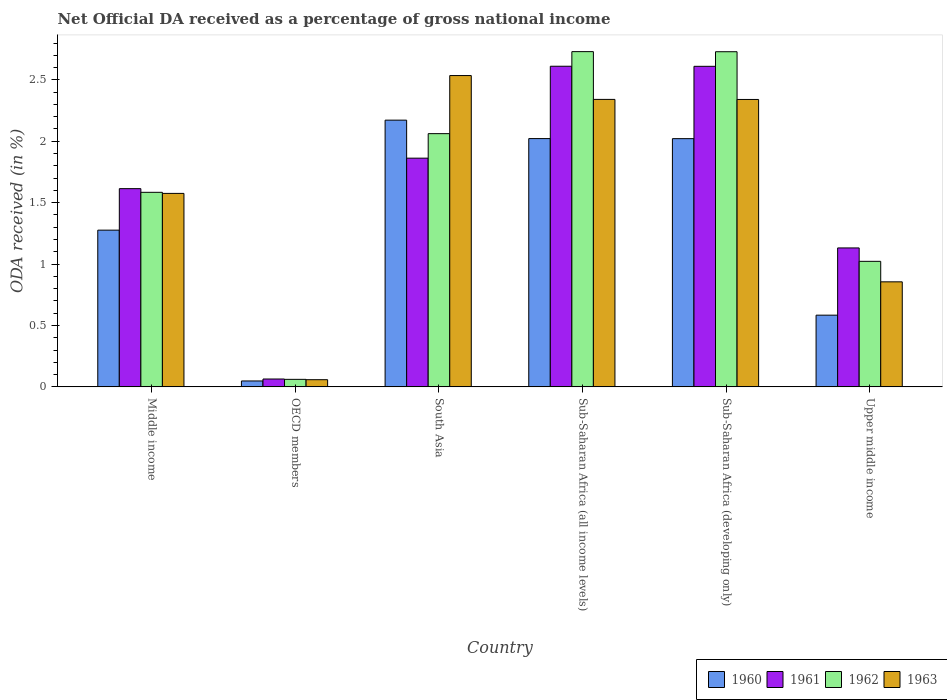How many different coloured bars are there?
Provide a succinct answer. 4. How many groups of bars are there?
Provide a succinct answer. 6. Are the number of bars per tick equal to the number of legend labels?
Your answer should be compact. Yes. Are the number of bars on each tick of the X-axis equal?
Provide a succinct answer. Yes. How many bars are there on the 3rd tick from the left?
Offer a very short reply. 4. How many bars are there on the 6th tick from the right?
Your response must be concise. 4. What is the net official DA received in 1962 in Middle income?
Your answer should be very brief. 1.58. Across all countries, what is the maximum net official DA received in 1960?
Make the answer very short. 2.17. Across all countries, what is the minimum net official DA received in 1961?
Ensure brevity in your answer.  0.06. What is the total net official DA received in 1962 in the graph?
Provide a short and direct response. 10.19. What is the difference between the net official DA received in 1963 in Middle income and that in Upper middle income?
Offer a terse response. 0.72. What is the difference between the net official DA received in 1962 in Upper middle income and the net official DA received in 1960 in Middle income?
Offer a terse response. -0.25. What is the average net official DA received in 1962 per country?
Give a very brief answer. 1.7. What is the difference between the net official DA received of/in 1963 and net official DA received of/in 1962 in Middle income?
Your answer should be very brief. -0.01. What is the ratio of the net official DA received in 1962 in South Asia to that in Sub-Saharan Africa (developing only)?
Provide a succinct answer. 0.76. Is the net official DA received in 1961 in Middle income less than that in South Asia?
Give a very brief answer. Yes. Is the difference between the net official DA received in 1963 in South Asia and Upper middle income greater than the difference between the net official DA received in 1962 in South Asia and Upper middle income?
Offer a very short reply. Yes. What is the difference between the highest and the second highest net official DA received in 1963?
Your answer should be very brief. 0.19. What is the difference between the highest and the lowest net official DA received in 1961?
Offer a very short reply. 2.55. Are all the bars in the graph horizontal?
Your response must be concise. No. What is the difference between two consecutive major ticks on the Y-axis?
Provide a short and direct response. 0.5. Does the graph contain any zero values?
Give a very brief answer. No. Where does the legend appear in the graph?
Offer a very short reply. Bottom right. How many legend labels are there?
Your answer should be compact. 4. How are the legend labels stacked?
Keep it short and to the point. Horizontal. What is the title of the graph?
Provide a succinct answer. Net Official DA received as a percentage of gross national income. Does "1983" appear as one of the legend labels in the graph?
Make the answer very short. No. What is the label or title of the Y-axis?
Your response must be concise. ODA received (in %). What is the ODA received (in %) of 1960 in Middle income?
Your answer should be compact. 1.28. What is the ODA received (in %) in 1961 in Middle income?
Give a very brief answer. 1.61. What is the ODA received (in %) of 1962 in Middle income?
Your response must be concise. 1.58. What is the ODA received (in %) of 1963 in Middle income?
Your response must be concise. 1.58. What is the ODA received (in %) of 1960 in OECD members?
Your answer should be very brief. 0.05. What is the ODA received (in %) in 1961 in OECD members?
Offer a terse response. 0.06. What is the ODA received (in %) in 1962 in OECD members?
Keep it short and to the point. 0.06. What is the ODA received (in %) in 1963 in OECD members?
Ensure brevity in your answer.  0.06. What is the ODA received (in %) of 1960 in South Asia?
Your response must be concise. 2.17. What is the ODA received (in %) in 1961 in South Asia?
Provide a short and direct response. 1.86. What is the ODA received (in %) in 1962 in South Asia?
Give a very brief answer. 2.06. What is the ODA received (in %) of 1963 in South Asia?
Keep it short and to the point. 2.53. What is the ODA received (in %) of 1960 in Sub-Saharan Africa (all income levels)?
Provide a short and direct response. 2.02. What is the ODA received (in %) of 1961 in Sub-Saharan Africa (all income levels)?
Your response must be concise. 2.61. What is the ODA received (in %) in 1962 in Sub-Saharan Africa (all income levels)?
Offer a terse response. 2.73. What is the ODA received (in %) in 1963 in Sub-Saharan Africa (all income levels)?
Your answer should be compact. 2.34. What is the ODA received (in %) of 1960 in Sub-Saharan Africa (developing only)?
Your answer should be compact. 2.02. What is the ODA received (in %) of 1961 in Sub-Saharan Africa (developing only)?
Provide a short and direct response. 2.61. What is the ODA received (in %) of 1962 in Sub-Saharan Africa (developing only)?
Keep it short and to the point. 2.73. What is the ODA received (in %) of 1963 in Sub-Saharan Africa (developing only)?
Your answer should be compact. 2.34. What is the ODA received (in %) of 1960 in Upper middle income?
Your response must be concise. 0.58. What is the ODA received (in %) of 1961 in Upper middle income?
Give a very brief answer. 1.13. What is the ODA received (in %) of 1962 in Upper middle income?
Offer a very short reply. 1.02. What is the ODA received (in %) of 1963 in Upper middle income?
Provide a succinct answer. 0.86. Across all countries, what is the maximum ODA received (in %) in 1960?
Your answer should be compact. 2.17. Across all countries, what is the maximum ODA received (in %) in 1961?
Provide a succinct answer. 2.61. Across all countries, what is the maximum ODA received (in %) of 1962?
Give a very brief answer. 2.73. Across all countries, what is the maximum ODA received (in %) of 1963?
Provide a short and direct response. 2.53. Across all countries, what is the minimum ODA received (in %) of 1960?
Provide a short and direct response. 0.05. Across all countries, what is the minimum ODA received (in %) of 1961?
Your answer should be very brief. 0.06. Across all countries, what is the minimum ODA received (in %) of 1962?
Your response must be concise. 0.06. Across all countries, what is the minimum ODA received (in %) in 1963?
Provide a succinct answer. 0.06. What is the total ODA received (in %) in 1960 in the graph?
Provide a short and direct response. 8.12. What is the total ODA received (in %) of 1961 in the graph?
Your response must be concise. 9.89. What is the total ODA received (in %) in 1962 in the graph?
Give a very brief answer. 10.19. What is the total ODA received (in %) in 1963 in the graph?
Make the answer very short. 9.71. What is the difference between the ODA received (in %) in 1960 in Middle income and that in OECD members?
Make the answer very short. 1.23. What is the difference between the ODA received (in %) in 1961 in Middle income and that in OECD members?
Offer a terse response. 1.55. What is the difference between the ODA received (in %) of 1962 in Middle income and that in OECD members?
Your answer should be very brief. 1.52. What is the difference between the ODA received (in %) of 1963 in Middle income and that in OECD members?
Give a very brief answer. 1.52. What is the difference between the ODA received (in %) in 1960 in Middle income and that in South Asia?
Offer a very short reply. -0.9. What is the difference between the ODA received (in %) in 1961 in Middle income and that in South Asia?
Ensure brevity in your answer.  -0.25. What is the difference between the ODA received (in %) in 1962 in Middle income and that in South Asia?
Make the answer very short. -0.48. What is the difference between the ODA received (in %) in 1963 in Middle income and that in South Asia?
Provide a succinct answer. -0.96. What is the difference between the ODA received (in %) in 1960 in Middle income and that in Sub-Saharan Africa (all income levels)?
Ensure brevity in your answer.  -0.75. What is the difference between the ODA received (in %) of 1961 in Middle income and that in Sub-Saharan Africa (all income levels)?
Provide a short and direct response. -1. What is the difference between the ODA received (in %) in 1962 in Middle income and that in Sub-Saharan Africa (all income levels)?
Give a very brief answer. -1.15. What is the difference between the ODA received (in %) of 1963 in Middle income and that in Sub-Saharan Africa (all income levels)?
Offer a terse response. -0.77. What is the difference between the ODA received (in %) in 1960 in Middle income and that in Sub-Saharan Africa (developing only)?
Your answer should be compact. -0.75. What is the difference between the ODA received (in %) in 1961 in Middle income and that in Sub-Saharan Africa (developing only)?
Make the answer very short. -1. What is the difference between the ODA received (in %) in 1962 in Middle income and that in Sub-Saharan Africa (developing only)?
Keep it short and to the point. -1.14. What is the difference between the ODA received (in %) in 1963 in Middle income and that in Sub-Saharan Africa (developing only)?
Make the answer very short. -0.76. What is the difference between the ODA received (in %) of 1960 in Middle income and that in Upper middle income?
Provide a short and direct response. 0.69. What is the difference between the ODA received (in %) of 1961 in Middle income and that in Upper middle income?
Make the answer very short. 0.48. What is the difference between the ODA received (in %) of 1962 in Middle income and that in Upper middle income?
Your answer should be very brief. 0.56. What is the difference between the ODA received (in %) of 1963 in Middle income and that in Upper middle income?
Ensure brevity in your answer.  0.72. What is the difference between the ODA received (in %) of 1960 in OECD members and that in South Asia?
Keep it short and to the point. -2.12. What is the difference between the ODA received (in %) in 1961 in OECD members and that in South Asia?
Ensure brevity in your answer.  -1.8. What is the difference between the ODA received (in %) of 1962 in OECD members and that in South Asia?
Give a very brief answer. -2. What is the difference between the ODA received (in %) in 1963 in OECD members and that in South Asia?
Your response must be concise. -2.48. What is the difference between the ODA received (in %) in 1960 in OECD members and that in Sub-Saharan Africa (all income levels)?
Offer a very short reply. -1.97. What is the difference between the ODA received (in %) of 1961 in OECD members and that in Sub-Saharan Africa (all income levels)?
Offer a terse response. -2.55. What is the difference between the ODA received (in %) in 1962 in OECD members and that in Sub-Saharan Africa (all income levels)?
Provide a short and direct response. -2.67. What is the difference between the ODA received (in %) in 1963 in OECD members and that in Sub-Saharan Africa (all income levels)?
Your answer should be very brief. -2.28. What is the difference between the ODA received (in %) in 1960 in OECD members and that in Sub-Saharan Africa (developing only)?
Give a very brief answer. -1.97. What is the difference between the ODA received (in %) of 1961 in OECD members and that in Sub-Saharan Africa (developing only)?
Provide a short and direct response. -2.55. What is the difference between the ODA received (in %) of 1962 in OECD members and that in Sub-Saharan Africa (developing only)?
Offer a very short reply. -2.67. What is the difference between the ODA received (in %) in 1963 in OECD members and that in Sub-Saharan Africa (developing only)?
Provide a succinct answer. -2.28. What is the difference between the ODA received (in %) of 1960 in OECD members and that in Upper middle income?
Give a very brief answer. -0.54. What is the difference between the ODA received (in %) of 1961 in OECD members and that in Upper middle income?
Your response must be concise. -1.07. What is the difference between the ODA received (in %) of 1962 in OECD members and that in Upper middle income?
Your answer should be compact. -0.96. What is the difference between the ODA received (in %) in 1963 in OECD members and that in Upper middle income?
Your answer should be compact. -0.8. What is the difference between the ODA received (in %) in 1960 in South Asia and that in Sub-Saharan Africa (all income levels)?
Provide a succinct answer. 0.15. What is the difference between the ODA received (in %) of 1961 in South Asia and that in Sub-Saharan Africa (all income levels)?
Your answer should be very brief. -0.75. What is the difference between the ODA received (in %) of 1962 in South Asia and that in Sub-Saharan Africa (all income levels)?
Ensure brevity in your answer.  -0.67. What is the difference between the ODA received (in %) in 1963 in South Asia and that in Sub-Saharan Africa (all income levels)?
Your answer should be compact. 0.19. What is the difference between the ODA received (in %) of 1960 in South Asia and that in Sub-Saharan Africa (developing only)?
Offer a very short reply. 0.15. What is the difference between the ODA received (in %) of 1961 in South Asia and that in Sub-Saharan Africa (developing only)?
Offer a terse response. -0.75. What is the difference between the ODA received (in %) of 1962 in South Asia and that in Sub-Saharan Africa (developing only)?
Offer a terse response. -0.67. What is the difference between the ODA received (in %) in 1963 in South Asia and that in Sub-Saharan Africa (developing only)?
Offer a terse response. 0.19. What is the difference between the ODA received (in %) of 1960 in South Asia and that in Upper middle income?
Provide a short and direct response. 1.59. What is the difference between the ODA received (in %) in 1961 in South Asia and that in Upper middle income?
Offer a very short reply. 0.73. What is the difference between the ODA received (in %) of 1962 in South Asia and that in Upper middle income?
Your answer should be very brief. 1.04. What is the difference between the ODA received (in %) in 1963 in South Asia and that in Upper middle income?
Make the answer very short. 1.68. What is the difference between the ODA received (in %) in 1961 in Sub-Saharan Africa (all income levels) and that in Sub-Saharan Africa (developing only)?
Provide a short and direct response. 0. What is the difference between the ODA received (in %) of 1962 in Sub-Saharan Africa (all income levels) and that in Sub-Saharan Africa (developing only)?
Your response must be concise. 0. What is the difference between the ODA received (in %) in 1963 in Sub-Saharan Africa (all income levels) and that in Sub-Saharan Africa (developing only)?
Keep it short and to the point. 0. What is the difference between the ODA received (in %) in 1960 in Sub-Saharan Africa (all income levels) and that in Upper middle income?
Your response must be concise. 1.44. What is the difference between the ODA received (in %) in 1961 in Sub-Saharan Africa (all income levels) and that in Upper middle income?
Your response must be concise. 1.48. What is the difference between the ODA received (in %) in 1962 in Sub-Saharan Africa (all income levels) and that in Upper middle income?
Provide a short and direct response. 1.71. What is the difference between the ODA received (in %) of 1963 in Sub-Saharan Africa (all income levels) and that in Upper middle income?
Give a very brief answer. 1.49. What is the difference between the ODA received (in %) in 1960 in Sub-Saharan Africa (developing only) and that in Upper middle income?
Offer a very short reply. 1.44. What is the difference between the ODA received (in %) in 1961 in Sub-Saharan Africa (developing only) and that in Upper middle income?
Your answer should be compact. 1.48. What is the difference between the ODA received (in %) of 1962 in Sub-Saharan Africa (developing only) and that in Upper middle income?
Your answer should be compact. 1.71. What is the difference between the ODA received (in %) of 1963 in Sub-Saharan Africa (developing only) and that in Upper middle income?
Keep it short and to the point. 1.49. What is the difference between the ODA received (in %) in 1960 in Middle income and the ODA received (in %) in 1961 in OECD members?
Give a very brief answer. 1.21. What is the difference between the ODA received (in %) of 1960 in Middle income and the ODA received (in %) of 1962 in OECD members?
Offer a very short reply. 1.21. What is the difference between the ODA received (in %) in 1960 in Middle income and the ODA received (in %) in 1963 in OECD members?
Your answer should be very brief. 1.22. What is the difference between the ODA received (in %) of 1961 in Middle income and the ODA received (in %) of 1962 in OECD members?
Give a very brief answer. 1.55. What is the difference between the ODA received (in %) in 1961 in Middle income and the ODA received (in %) in 1963 in OECD members?
Your answer should be compact. 1.56. What is the difference between the ODA received (in %) of 1962 in Middle income and the ODA received (in %) of 1963 in OECD members?
Provide a short and direct response. 1.53. What is the difference between the ODA received (in %) of 1960 in Middle income and the ODA received (in %) of 1961 in South Asia?
Offer a terse response. -0.59. What is the difference between the ODA received (in %) in 1960 in Middle income and the ODA received (in %) in 1962 in South Asia?
Your response must be concise. -0.79. What is the difference between the ODA received (in %) in 1960 in Middle income and the ODA received (in %) in 1963 in South Asia?
Ensure brevity in your answer.  -1.26. What is the difference between the ODA received (in %) of 1961 in Middle income and the ODA received (in %) of 1962 in South Asia?
Offer a terse response. -0.45. What is the difference between the ODA received (in %) of 1961 in Middle income and the ODA received (in %) of 1963 in South Asia?
Your answer should be very brief. -0.92. What is the difference between the ODA received (in %) of 1962 in Middle income and the ODA received (in %) of 1963 in South Asia?
Provide a succinct answer. -0.95. What is the difference between the ODA received (in %) of 1960 in Middle income and the ODA received (in %) of 1961 in Sub-Saharan Africa (all income levels)?
Provide a short and direct response. -1.33. What is the difference between the ODA received (in %) of 1960 in Middle income and the ODA received (in %) of 1962 in Sub-Saharan Africa (all income levels)?
Provide a succinct answer. -1.45. What is the difference between the ODA received (in %) in 1960 in Middle income and the ODA received (in %) in 1963 in Sub-Saharan Africa (all income levels)?
Your answer should be compact. -1.06. What is the difference between the ODA received (in %) of 1961 in Middle income and the ODA received (in %) of 1962 in Sub-Saharan Africa (all income levels)?
Provide a short and direct response. -1.12. What is the difference between the ODA received (in %) in 1961 in Middle income and the ODA received (in %) in 1963 in Sub-Saharan Africa (all income levels)?
Ensure brevity in your answer.  -0.73. What is the difference between the ODA received (in %) of 1962 in Middle income and the ODA received (in %) of 1963 in Sub-Saharan Africa (all income levels)?
Offer a terse response. -0.76. What is the difference between the ODA received (in %) of 1960 in Middle income and the ODA received (in %) of 1961 in Sub-Saharan Africa (developing only)?
Provide a short and direct response. -1.33. What is the difference between the ODA received (in %) in 1960 in Middle income and the ODA received (in %) in 1962 in Sub-Saharan Africa (developing only)?
Keep it short and to the point. -1.45. What is the difference between the ODA received (in %) in 1960 in Middle income and the ODA received (in %) in 1963 in Sub-Saharan Africa (developing only)?
Provide a short and direct response. -1.06. What is the difference between the ODA received (in %) of 1961 in Middle income and the ODA received (in %) of 1962 in Sub-Saharan Africa (developing only)?
Offer a very short reply. -1.11. What is the difference between the ODA received (in %) of 1961 in Middle income and the ODA received (in %) of 1963 in Sub-Saharan Africa (developing only)?
Offer a terse response. -0.73. What is the difference between the ODA received (in %) of 1962 in Middle income and the ODA received (in %) of 1963 in Sub-Saharan Africa (developing only)?
Offer a very short reply. -0.76. What is the difference between the ODA received (in %) of 1960 in Middle income and the ODA received (in %) of 1961 in Upper middle income?
Your answer should be very brief. 0.14. What is the difference between the ODA received (in %) in 1960 in Middle income and the ODA received (in %) in 1962 in Upper middle income?
Provide a succinct answer. 0.25. What is the difference between the ODA received (in %) of 1960 in Middle income and the ODA received (in %) of 1963 in Upper middle income?
Make the answer very short. 0.42. What is the difference between the ODA received (in %) of 1961 in Middle income and the ODA received (in %) of 1962 in Upper middle income?
Make the answer very short. 0.59. What is the difference between the ODA received (in %) of 1961 in Middle income and the ODA received (in %) of 1963 in Upper middle income?
Provide a succinct answer. 0.76. What is the difference between the ODA received (in %) in 1962 in Middle income and the ODA received (in %) in 1963 in Upper middle income?
Make the answer very short. 0.73. What is the difference between the ODA received (in %) of 1960 in OECD members and the ODA received (in %) of 1961 in South Asia?
Offer a terse response. -1.81. What is the difference between the ODA received (in %) of 1960 in OECD members and the ODA received (in %) of 1962 in South Asia?
Provide a short and direct response. -2.01. What is the difference between the ODA received (in %) in 1960 in OECD members and the ODA received (in %) in 1963 in South Asia?
Make the answer very short. -2.49. What is the difference between the ODA received (in %) in 1961 in OECD members and the ODA received (in %) in 1962 in South Asia?
Your answer should be very brief. -2. What is the difference between the ODA received (in %) of 1961 in OECD members and the ODA received (in %) of 1963 in South Asia?
Make the answer very short. -2.47. What is the difference between the ODA received (in %) in 1962 in OECD members and the ODA received (in %) in 1963 in South Asia?
Provide a succinct answer. -2.47. What is the difference between the ODA received (in %) in 1960 in OECD members and the ODA received (in %) in 1961 in Sub-Saharan Africa (all income levels)?
Ensure brevity in your answer.  -2.56. What is the difference between the ODA received (in %) of 1960 in OECD members and the ODA received (in %) of 1962 in Sub-Saharan Africa (all income levels)?
Provide a short and direct response. -2.68. What is the difference between the ODA received (in %) in 1960 in OECD members and the ODA received (in %) in 1963 in Sub-Saharan Africa (all income levels)?
Offer a very short reply. -2.29. What is the difference between the ODA received (in %) of 1961 in OECD members and the ODA received (in %) of 1962 in Sub-Saharan Africa (all income levels)?
Your response must be concise. -2.67. What is the difference between the ODA received (in %) of 1961 in OECD members and the ODA received (in %) of 1963 in Sub-Saharan Africa (all income levels)?
Provide a succinct answer. -2.28. What is the difference between the ODA received (in %) in 1962 in OECD members and the ODA received (in %) in 1963 in Sub-Saharan Africa (all income levels)?
Your answer should be very brief. -2.28. What is the difference between the ODA received (in %) of 1960 in OECD members and the ODA received (in %) of 1961 in Sub-Saharan Africa (developing only)?
Offer a terse response. -2.56. What is the difference between the ODA received (in %) in 1960 in OECD members and the ODA received (in %) in 1962 in Sub-Saharan Africa (developing only)?
Offer a very short reply. -2.68. What is the difference between the ODA received (in %) in 1960 in OECD members and the ODA received (in %) in 1963 in Sub-Saharan Africa (developing only)?
Offer a very short reply. -2.29. What is the difference between the ODA received (in %) in 1961 in OECD members and the ODA received (in %) in 1962 in Sub-Saharan Africa (developing only)?
Provide a succinct answer. -2.67. What is the difference between the ODA received (in %) of 1961 in OECD members and the ODA received (in %) of 1963 in Sub-Saharan Africa (developing only)?
Make the answer very short. -2.28. What is the difference between the ODA received (in %) in 1962 in OECD members and the ODA received (in %) in 1963 in Sub-Saharan Africa (developing only)?
Your response must be concise. -2.28. What is the difference between the ODA received (in %) of 1960 in OECD members and the ODA received (in %) of 1961 in Upper middle income?
Your answer should be compact. -1.08. What is the difference between the ODA received (in %) in 1960 in OECD members and the ODA received (in %) in 1962 in Upper middle income?
Keep it short and to the point. -0.97. What is the difference between the ODA received (in %) in 1960 in OECD members and the ODA received (in %) in 1963 in Upper middle income?
Your response must be concise. -0.81. What is the difference between the ODA received (in %) of 1961 in OECD members and the ODA received (in %) of 1962 in Upper middle income?
Make the answer very short. -0.96. What is the difference between the ODA received (in %) in 1961 in OECD members and the ODA received (in %) in 1963 in Upper middle income?
Ensure brevity in your answer.  -0.79. What is the difference between the ODA received (in %) of 1962 in OECD members and the ODA received (in %) of 1963 in Upper middle income?
Provide a succinct answer. -0.79. What is the difference between the ODA received (in %) in 1960 in South Asia and the ODA received (in %) in 1961 in Sub-Saharan Africa (all income levels)?
Provide a succinct answer. -0.44. What is the difference between the ODA received (in %) in 1960 in South Asia and the ODA received (in %) in 1962 in Sub-Saharan Africa (all income levels)?
Provide a succinct answer. -0.56. What is the difference between the ODA received (in %) of 1960 in South Asia and the ODA received (in %) of 1963 in Sub-Saharan Africa (all income levels)?
Offer a terse response. -0.17. What is the difference between the ODA received (in %) of 1961 in South Asia and the ODA received (in %) of 1962 in Sub-Saharan Africa (all income levels)?
Your answer should be compact. -0.87. What is the difference between the ODA received (in %) in 1961 in South Asia and the ODA received (in %) in 1963 in Sub-Saharan Africa (all income levels)?
Provide a short and direct response. -0.48. What is the difference between the ODA received (in %) of 1962 in South Asia and the ODA received (in %) of 1963 in Sub-Saharan Africa (all income levels)?
Ensure brevity in your answer.  -0.28. What is the difference between the ODA received (in %) of 1960 in South Asia and the ODA received (in %) of 1961 in Sub-Saharan Africa (developing only)?
Your response must be concise. -0.44. What is the difference between the ODA received (in %) in 1960 in South Asia and the ODA received (in %) in 1962 in Sub-Saharan Africa (developing only)?
Provide a short and direct response. -0.56. What is the difference between the ODA received (in %) of 1960 in South Asia and the ODA received (in %) of 1963 in Sub-Saharan Africa (developing only)?
Give a very brief answer. -0.17. What is the difference between the ODA received (in %) in 1961 in South Asia and the ODA received (in %) in 1962 in Sub-Saharan Africa (developing only)?
Your answer should be very brief. -0.87. What is the difference between the ODA received (in %) in 1961 in South Asia and the ODA received (in %) in 1963 in Sub-Saharan Africa (developing only)?
Your answer should be very brief. -0.48. What is the difference between the ODA received (in %) in 1962 in South Asia and the ODA received (in %) in 1963 in Sub-Saharan Africa (developing only)?
Your answer should be compact. -0.28. What is the difference between the ODA received (in %) of 1960 in South Asia and the ODA received (in %) of 1961 in Upper middle income?
Your response must be concise. 1.04. What is the difference between the ODA received (in %) in 1960 in South Asia and the ODA received (in %) in 1962 in Upper middle income?
Keep it short and to the point. 1.15. What is the difference between the ODA received (in %) in 1960 in South Asia and the ODA received (in %) in 1963 in Upper middle income?
Your response must be concise. 1.32. What is the difference between the ODA received (in %) in 1961 in South Asia and the ODA received (in %) in 1962 in Upper middle income?
Your answer should be very brief. 0.84. What is the difference between the ODA received (in %) of 1961 in South Asia and the ODA received (in %) of 1963 in Upper middle income?
Provide a short and direct response. 1.01. What is the difference between the ODA received (in %) in 1962 in South Asia and the ODA received (in %) in 1963 in Upper middle income?
Provide a short and direct response. 1.21. What is the difference between the ODA received (in %) of 1960 in Sub-Saharan Africa (all income levels) and the ODA received (in %) of 1961 in Sub-Saharan Africa (developing only)?
Give a very brief answer. -0.59. What is the difference between the ODA received (in %) in 1960 in Sub-Saharan Africa (all income levels) and the ODA received (in %) in 1962 in Sub-Saharan Africa (developing only)?
Your answer should be very brief. -0.71. What is the difference between the ODA received (in %) of 1960 in Sub-Saharan Africa (all income levels) and the ODA received (in %) of 1963 in Sub-Saharan Africa (developing only)?
Offer a terse response. -0.32. What is the difference between the ODA received (in %) of 1961 in Sub-Saharan Africa (all income levels) and the ODA received (in %) of 1962 in Sub-Saharan Africa (developing only)?
Ensure brevity in your answer.  -0.12. What is the difference between the ODA received (in %) in 1961 in Sub-Saharan Africa (all income levels) and the ODA received (in %) in 1963 in Sub-Saharan Africa (developing only)?
Make the answer very short. 0.27. What is the difference between the ODA received (in %) of 1962 in Sub-Saharan Africa (all income levels) and the ODA received (in %) of 1963 in Sub-Saharan Africa (developing only)?
Ensure brevity in your answer.  0.39. What is the difference between the ODA received (in %) of 1960 in Sub-Saharan Africa (all income levels) and the ODA received (in %) of 1961 in Upper middle income?
Keep it short and to the point. 0.89. What is the difference between the ODA received (in %) of 1960 in Sub-Saharan Africa (all income levels) and the ODA received (in %) of 1963 in Upper middle income?
Ensure brevity in your answer.  1.17. What is the difference between the ODA received (in %) in 1961 in Sub-Saharan Africa (all income levels) and the ODA received (in %) in 1962 in Upper middle income?
Ensure brevity in your answer.  1.59. What is the difference between the ODA received (in %) of 1961 in Sub-Saharan Africa (all income levels) and the ODA received (in %) of 1963 in Upper middle income?
Your response must be concise. 1.76. What is the difference between the ODA received (in %) of 1962 in Sub-Saharan Africa (all income levels) and the ODA received (in %) of 1963 in Upper middle income?
Make the answer very short. 1.87. What is the difference between the ODA received (in %) of 1960 in Sub-Saharan Africa (developing only) and the ODA received (in %) of 1961 in Upper middle income?
Provide a succinct answer. 0.89. What is the difference between the ODA received (in %) of 1960 in Sub-Saharan Africa (developing only) and the ODA received (in %) of 1963 in Upper middle income?
Your answer should be compact. 1.17. What is the difference between the ODA received (in %) in 1961 in Sub-Saharan Africa (developing only) and the ODA received (in %) in 1962 in Upper middle income?
Your answer should be very brief. 1.59. What is the difference between the ODA received (in %) in 1961 in Sub-Saharan Africa (developing only) and the ODA received (in %) in 1963 in Upper middle income?
Your answer should be very brief. 1.75. What is the difference between the ODA received (in %) of 1962 in Sub-Saharan Africa (developing only) and the ODA received (in %) of 1963 in Upper middle income?
Give a very brief answer. 1.87. What is the average ODA received (in %) in 1960 per country?
Give a very brief answer. 1.35. What is the average ODA received (in %) in 1961 per country?
Your answer should be very brief. 1.65. What is the average ODA received (in %) in 1962 per country?
Provide a succinct answer. 1.7. What is the average ODA received (in %) of 1963 per country?
Ensure brevity in your answer.  1.62. What is the difference between the ODA received (in %) of 1960 and ODA received (in %) of 1961 in Middle income?
Keep it short and to the point. -0.34. What is the difference between the ODA received (in %) in 1960 and ODA received (in %) in 1962 in Middle income?
Your response must be concise. -0.31. What is the difference between the ODA received (in %) of 1960 and ODA received (in %) of 1963 in Middle income?
Provide a succinct answer. -0.3. What is the difference between the ODA received (in %) of 1961 and ODA received (in %) of 1962 in Middle income?
Provide a succinct answer. 0.03. What is the difference between the ODA received (in %) of 1961 and ODA received (in %) of 1963 in Middle income?
Provide a short and direct response. 0.04. What is the difference between the ODA received (in %) in 1962 and ODA received (in %) in 1963 in Middle income?
Keep it short and to the point. 0.01. What is the difference between the ODA received (in %) in 1960 and ODA received (in %) in 1961 in OECD members?
Your answer should be very brief. -0.02. What is the difference between the ODA received (in %) of 1960 and ODA received (in %) of 1962 in OECD members?
Offer a very short reply. -0.01. What is the difference between the ODA received (in %) in 1960 and ODA received (in %) in 1963 in OECD members?
Offer a terse response. -0.01. What is the difference between the ODA received (in %) of 1961 and ODA received (in %) of 1962 in OECD members?
Provide a short and direct response. 0. What is the difference between the ODA received (in %) of 1961 and ODA received (in %) of 1963 in OECD members?
Offer a very short reply. 0.01. What is the difference between the ODA received (in %) in 1962 and ODA received (in %) in 1963 in OECD members?
Give a very brief answer. 0. What is the difference between the ODA received (in %) of 1960 and ODA received (in %) of 1961 in South Asia?
Make the answer very short. 0.31. What is the difference between the ODA received (in %) of 1960 and ODA received (in %) of 1962 in South Asia?
Your answer should be very brief. 0.11. What is the difference between the ODA received (in %) of 1960 and ODA received (in %) of 1963 in South Asia?
Provide a succinct answer. -0.36. What is the difference between the ODA received (in %) of 1961 and ODA received (in %) of 1962 in South Asia?
Your answer should be very brief. -0.2. What is the difference between the ODA received (in %) in 1961 and ODA received (in %) in 1963 in South Asia?
Make the answer very short. -0.67. What is the difference between the ODA received (in %) of 1962 and ODA received (in %) of 1963 in South Asia?
Offer a very short reply. -0.47. What is the difference between the ODA received (in %) in 1960 and ODA received (in %) in 1961 in Sub-Saharan Africa (all income levels)?
Provide a succinct answer. -0.59. What is the difference between the ODA received (in %) of 1960 and ODA received (in %) of 1962 in Sub-Saharan Africa (all income levels)?
Make the answer very short. -0.71. What is the difference between the ODA received (in %) in 1960 and ODA received (in %) in 1963 in Sub-Saharan Africa (all income levels)?
Offer a very short reply. -0.32. What is the difference between the ODA received (in %) in 1961 and ODA received (in %) in 1962 in Sub-Saharan Africa (all income levels)?
Your answer should be very brief. -0.12. What is the difference between the ODA received (in %) in 1961 and ODA received (in %) in 1963 in Sub-Saharan Africa (all income levels)?
Offer a terse response. 0.27. What is the difference between the ODA received (in %) in 1962 and ODA received (in %) in 1963 in Sub-Saharan Africa (all income levels)?
Make the answer very short. 0.39. What is the difference between the ODA received (in %) in 1960 and ODA received (in %) in 1961 in Sub-Saharan Africa (developing only)?
Give a very brief answer. -0.59. What is the difference between the ODA received (in %) in 1960 and ODA received (in %) in 1962 in Sub-Saharan Africa (developing only)?
Your response must be concise. -0.71. What is the difference between the ODA received (in %) in 1960 and ODA received (in %) in 1963 in Sub-Saharan Africa (developing only)?
Offer a very short reply. -0.32. What is the difference between the ODA received (in %) of 1961 and ODA received (in %) of 1962 in Sub-Saharan Africa (developing only)?
Offer a terse response. -0.12. What is the difference between the ODA received (in %) of 1961 and ODA received (in %) of 1963 in Sub-Saharan Africa (developing only)?
Your answer should be very brief. 0.27. What is the difference between the ODA received (in %) in 1962 and ODA received (in %) in 1963 in Sub-Saharan Africa (developing only)?
Offer a terse response. 0.39. What is the difference between the ODA received (in %) of 1960 and ODA received (in %) of 1961 in Upper middle income?
Your response must be concise. -0.55. What is the difference between the ODA received (in %) in 1960 and ODA received (in %) in 1962 in Upper middle income?
Provide a succinct answer. -0.44. What is the difference between the ODA received (in %) of 1960 and ODA received (in %) of 1963 in Upper middle income?
Your answer should be very brief. -0.27. What is the difference between the ODA received (in %) of 1961 and ODA received (in %) of 1962 in Upper middle income?
Keep it short and to the point. 0.11. What is the difference between the ODA received (in %) in 1961 and ODA received (in %) in 1963 in Upper middle income?
Keep it short and to the point. 0.28. What is the difference between the ODA received (in %) in 1962 and ODA received (in %) in 1963 in Upper middle income?
Keep it short and to the point. 0.17. What is the ratio of the ODA received (in %) of 1960 in Middle income to that in OECD members?
Offer a terse response. 26.52. What is the ratio of the ODA received (in %) of 1961 in Middle income to that in OECD members?
Your answer should be very brief. 25.19. What is the ratio of the ODA received (in %) in 1962 in Middle income to that in OECD members?
Your response must be concise. 25.88. What is the ratio of the ODA received (in %) in 1963 in Middle income to that in OECD members?
Make the answer very short. 26.93. What is the ratio of the ODA received (in %) of 1960 in Middle income to that in South Asia?
Your answer should be very brief. 0.59. What is the ratio of the ODA received (in %) of 1961 in Middle income to that in South Asia?
Your answer should be very brief. 0.87. What is the ratio of the ODA received (in %) of 1962 in Middle income to that in South Asia?
Your answer should be very brief. 0.77. What is the ratio of the ODA received (in %) in 1963 in Middle income to that in South Asia?
Make the answer very short. 0.62. What is the ratio of the ODA received (in %) of 1960 in Middle income to that in Sub-Saharan Africa (all income levels)?
Your answer should be very brief. 0.63. What is the ratio of the ODA received (in %) of 1961 in Middle income to that in Sub-Saharan Africa (all income levels)?
Provide a succinct answer. 0.62. What is the ratio of the ODA received (in %) of 1962 in Middle income to that in Sub-Saharan Africa (all income levels)?
Give a very brief answer. 0.58. What is the ratio of the ODA received (in %) in 1963 in Middle income to that in Sub-Saharan Africa (all income levels)?
Your answer should be compact. 0.67. What is the ratio of the ODA received (in %) in 1960 in Middle income to that in Sub-Saharan Africa (developing only)?
Ensure brevity in your answer.  0.63. What is the ratio of the ODA received (in %) of 1961 in Middle income to that in Sub-Saharan Africa (developing only)?
Give a very brief answer. 0.62. What is the ratio of the ODA received (in %) in 1962 in Middle income to that in Sub-Saharan Africa (developing only)?
Ensure brevity in your answer.  0.58. What is the ratio of the ODA received (in %) of 1963 in Middle income to that in Sub-Saharan Africa (developing only)?
Keep it short and to the point. 0.67. What is the ratio of the ODA received (in %) of 1960 in Middle income to that in Upper middle income?
Provide a short and direct response. 2.19. What is the ratio of the ODA received (in %) in 1961 in Middle income to that in Upper middle income?
Make the answer very short. 1.43. What is the ratio of the ODA received (in %) of 1962 in Middle income to that in Upper middle income?
Give a very brief answer. 1.55. What is the ratio of the ODA received (in %) of 1963 in Middle income to that in Upper middle income?
Your answer should be very brief. 1.84. What is the ratio of the ODA received (in %) in 1960 in OECD members to that in South Asia?
Offer a very short reply. 0.02. What is the ratio of the ODA received (in %) of 1961 in OECD members to that in South Asia?
Keep it short and to the point. 0.03. What is the ratio of the ODA received (in %) of 1962 in OECD members to that in South Asia?
Your answer should be compact. 0.03. What is the ratio of the ODA received (in %) of 1963 in OECD members to that in South Asia?
Offer a terse response. 0.02. What is the ratio of the ODA received (in %) of 1960 in OECD members to that in Sub-Saharan Africa (all income levels)?
Give a very brief answer. 0.02. What is the ratio of the ODA received (in %) of 1961 in OECD members to that in Sub-Saharan Africa (all income levels)?
Keep it short and to the point. 0.02. What is the ratio of the ODA received (in %) of 1962 in OECD members to that in Sub-Saharan Africa (all income levels)?
Provide a succinct answer. 0.02. What is the ratio of the ODA received (in %) of 1963 in OECD members to that in Sub-Saharan Africa (all income levels)?
Your response must be concise. 0.03. What is the ratio of the ODA received (in %) in 1960 in OECD members to that in Sub-Saharan Africa (developing only)?
Offer a very short reply. 0.02. What is the ratio of the ODA received (in %) in 1961 in OECD members to that in Sub-Saharan Africa (developing only)?
Ensure brevity in your answer.  0.02. What is the ratio of the ODA received (in %) of 1962 in OECD members to that in Sub-Saharan Africa (developing only)?
Provide a short and direct response. 0.02. What is the ratio of the ODA received (in %) in 1963 in OECD members to that in Sub-Saharan Africa (developing only)?
Provide a succinct answer. 0.03. What is the ratio of the ODA received (in %) in 1960 in OECD members to that in Upper middle income?
Provide a short and direct response. 0.08. What is the ratio of the ODA received (in %) of 1961 in OECD members to that in Upper middle income?
Make the answer very short. 0.06. What is the ratio of the ODA received (in %) of 1962 in OECD members to that in Upper middle income?
Offer a terse response. 0.06. What is the ratio of the ODA received (in %) in 1963 in OECD members to that in Upper middle income?
Your response must be concise. 0.07. What is the ratio of the ODA received (in %) of 1960 in South Asia to that in Sub-Saharan Africa (all income levels)?
Your answer should be very brief. 1.07. What is the ratio of the ODA received (in %) of 1961 in South Asia to that in Sub-Saharan Africa (all income levels)?
Ensure brevity in your answer.  0.71. What is the ratio of the ODA received (in %) in 1962 in South Asia to that in Sub-Saharan Africa (all income levels)?
Offer a terse response. 0.76. What is the ratio of the ODA received (in %) in 1963 in South Asia to that in Sub-Saharan Africa (all income levels)?
Offer a terse response. 1.08. What is the ratio of the ODA received (in %) in 1960 in South Asia to that in Sub-Saharan Africa (developing only)?
Give a very brief answer. 1.07. What is the ratio of the ODA received (in %) of 1961 in South Asia to that in Sub-Saharan Africa (developing only)?
Your response must be concise. 0.71. What is the ratio of the ODA received (in %) of 1962 in South Asia to that in Sub-Saharan Africa (developing only)?
Your response must be concise. 0.76. What is the ratio of the ODA received (in %) in 1963 in South Asia to that in Sub-Saharan Africa (developing only)?
Offer a terse response. 1.08. What is the ratio of the ODA received (in %) in 1960 in South Asia to that in Upper middle income?
Provide a short and direct response. 3.72. What is the ratio of the ODA received (in %) in 1961 in South Asia to that in Upper middle income?
Give a very brief answer. 1.65. What is the ratio of the ODA received (in %) in 1962 in South Asia to that in Upper middle income?
Offer a terse response. 2.02. What is the ratio of the ODA received (in %) in 1963 in South Asia to that in Upper middle income?
Give a very brief answer. 2.96. What is the ratio of the ODA received (in %) of 1962 in Sub-Saharan Africa (all income levels) to that in Sub-Saharan Africa (developing only)?
Your response must be concise. 1. What is the ratio of the ODA received (in %) in 1963 in Sub-Saharan Africa (all income levels) to that in Sub-Saharan Africa (developing only)?
Make the answer very short. 1. What is the ratio of the ODA received (in %) of 1960 in Sub-Saharan Africa (all income levels) to that in Upper middle income?
Your answer should be compact. 3.46. What is the ratio of the ODA received (in %) in 1961 in Sub-Saharan Africa (all income levels) to that in Upper middle income?
Your answer should be compact. 2.31. What is the ratio of the ODA received (in %) of 1962 in Sub-Saharan Africa (all income levels) to that in Upper middle income?
Ensure brevity in your answer.  2.67. What is the ratio of the ODA received (in %) of 1963 in Sub-Saharan Africa (all income levels) to that in Upper middle income?
Provide a short and direct response. 2.74. What is the ratio of the ODA received (in %) of 1960 in Sub-Saharan Africa (developing only) to that in Upper middle income?
Provide a succinct answer. 3.46. What is the ratio of the ODA received (in %) of 1961 in Sub-Saharan Africa (developing only) to that in Upper middle income?
Ensure brevity in your answer.  2.31. What is the ratio of the ODA received (in %) in 1962 in Sub-Saharan Africa (developing only) to that in Upper middle income?
Provide a short and direct response. 2.67. What is the ratio of the ODA received (in %) in 1963 in Sub-Saharan Africa (developing only) to that in Upper middle income?
Your answer should be compact. 2.74. What is the difference between the highest and the second highest ODA received (in %) of 1960?
Make the answer very short. 0.15. What is the difference between the highest and the second highest ODA received (in %) in 1961?
Offer a terse response. 0. What is the difference between the highest and the second highest ODA received (in %) of 1962?
Provide a short and direct response. 0. What is the difference between the highest and the second highest ODA received (in %) in 1963?
Provide a short and direct response. 0.19. What is the difference between the highest and the lowest ODA received (in %) of 1960?
Provide a succinct answer. 2.12. What is the difference between the highest and the lowest ODA received (in %) in 1961?
Ensure brevity in your answer.  2.55. What is the difference between the highest and the lowest ODA received (in %) of 1962?
Provide a short and direct response. 2.67. What is the difference between the highest and the lowest ODA received (in %) in 1963?
Provide a succinct answer. 2.48. 